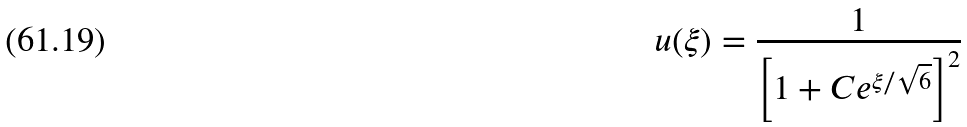<formula> <loc_0><loc_0><loc_500><loc_500>u ( \xi ) = \frac { 1 } { \left [ 1 + C e ^ { \xi / \sqrt { 6 } } \right ] ^ { 2 } }</formula> 